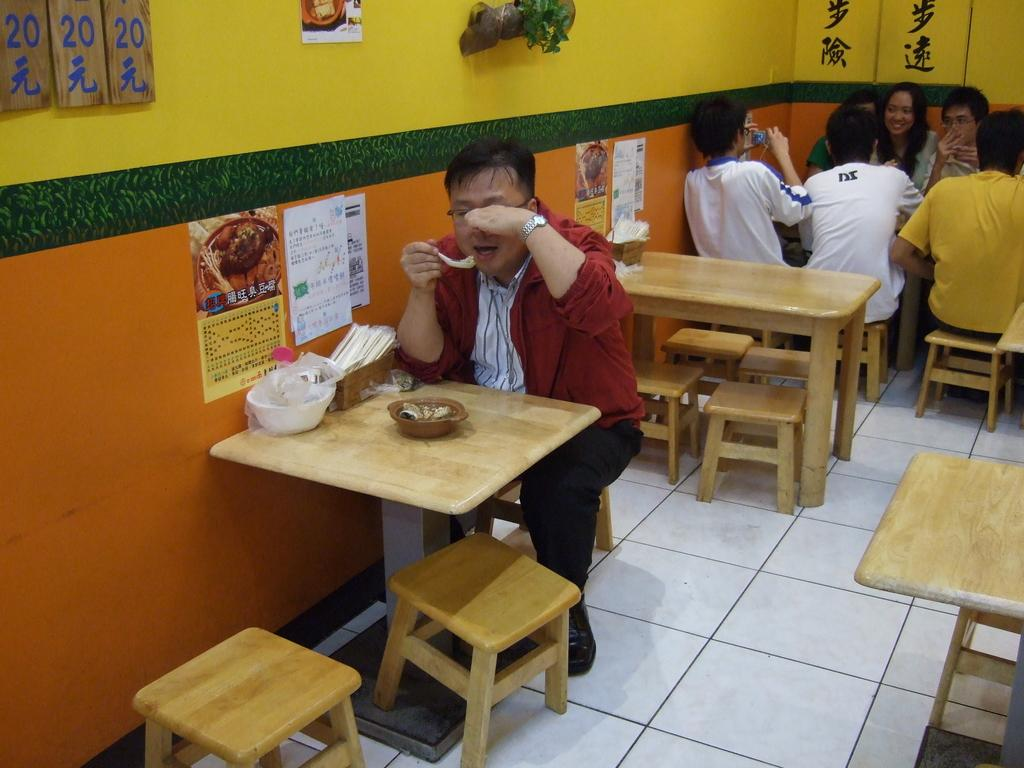What is the main subject in the center of the image? There is a person sitting on a chair in the center of the image. What is the person doing in the image? The person is having food. Where are the other people located in the image? There is a group of people sitting on chairs on the right side of the image. What is the mood of the group of people in the image? The group of people are smiling. How many minutes does it take for the plantation to grow in the image? There is no plantation present in the image, so it is not possible to determine how long it takes for it to grow. 